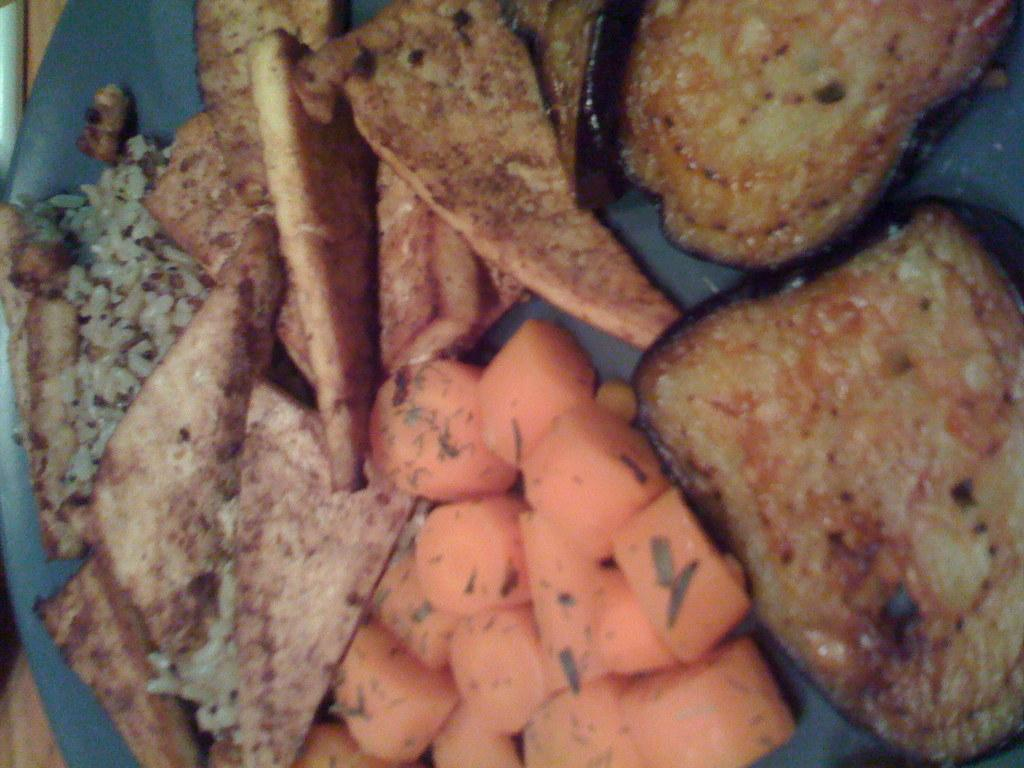What is present on the plate in the image? There is a plate in the image, and it has breads and other food items on it. Can you describe the breads on the plate? The breads on the plate are not specified in detail, but they are visible on the plate. What other food items are on the plate? The other food items on the plate are not specified in detail, but they are visible along with the breads. How many frogs are sitting on the plate in the image? There are no frogs present on the plate in the image. Is there a spy observing the food items on the plate in the image? There is no mention of a spy or any person observing the food items in the image. 